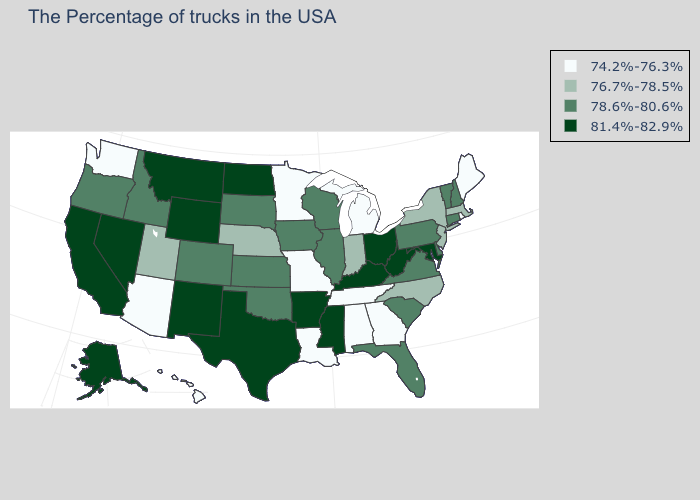Which states have the lowest value in the USA?
Give a very brief answer. Maine, Rhode Island, Georgia, Michigan, Alabama, Tennessee, Louisiana, Missouri, Minnesota, Arizona, Washington, Hawaii. Among the states that border Florida , which have the highest value?
Keep it brief. Georgia, Alabama. Does the map have missing data?
Write a very short answer. No. What is the value of Minnesota?
Write a very short answer. 74.2%-76.3%. Name the states that have a value in the range 81.4%-82.9%?
Answer briefly. Maryland, West Virginia, Ohio, Kentucky, Mississippi, Arkansas, Texas, North Dakota, Wyoming, New Mexico, Montana, Nevada, California, Alaska. Which states have the lowest value in the USA?
Give a very brief answer. Maine, Rhode Island, Georgia, Michigan, Alabama, Tennessee, Louisiana, Missouri, Minnesota, Arizona, Washington, Hawaii. What is the value of Nebraska?
Write a very short answer. 76.7%-78.5%. Name the states that have a value in the range 76.7%-78.5%?
Keep it brief. Massachusetts, New York, New Jersey, North Carolina, Indiana, Nebraska, Utah. What is the lowest value in states that border New Jersey?
Write a very short answer. 76.7%-78.5%. Which states have the lowest value in the USA?
Answer briefly. Maine, Rhode Island, Georgia, Michigan, Alabama, Tennessee, Louisiana, Missouri, Minnesota, Arizona, Washington, Hawaii. Does Arizona have a lower value than North Carolina?
Answer briefly. Yes. Does California have the highest value in the USA?
Write a very short answer. Yes. Which states have the lowest value in the South?
Short answer required. Georgia, Alabama, Tennessee, Louisiana. Is the legend a continuous bar?
Concise answer only. No. Name the states that have a value in the range 76.7%-78.5%?
Answer briefly. Massachusetts, New York, New Jersey, North Carolina, Indiana, Nebraska, Utah. 